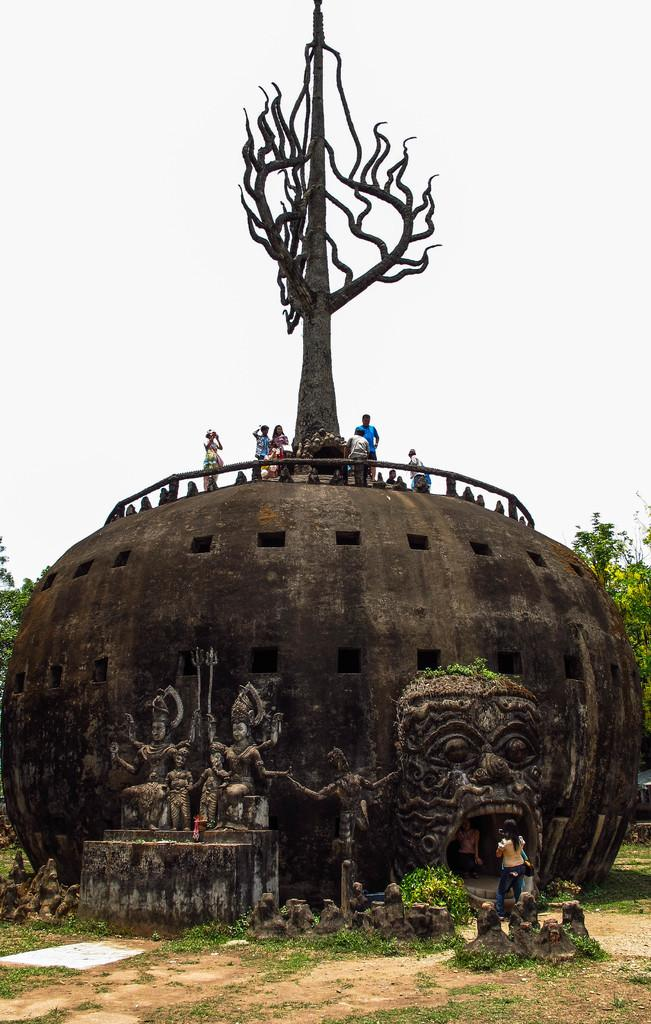What is the main setting of the image? There is a land in the image. Who or what can be seen on the land? There is a girl standing on the land. What can be seen in the background of the image? There is a monument and trees visible in the background of the image. Can you describe the people in the image? There are people standing on top of the monument. What is visible in the sky in the image? The sky is visible in the background of the image. What type of pan is the girl using to cook on the land? There is no pan or cooking activity present in the image. Can you tell me how many mothers are visible in the image? There is no mention of a mother or any maternal figure in the image. 